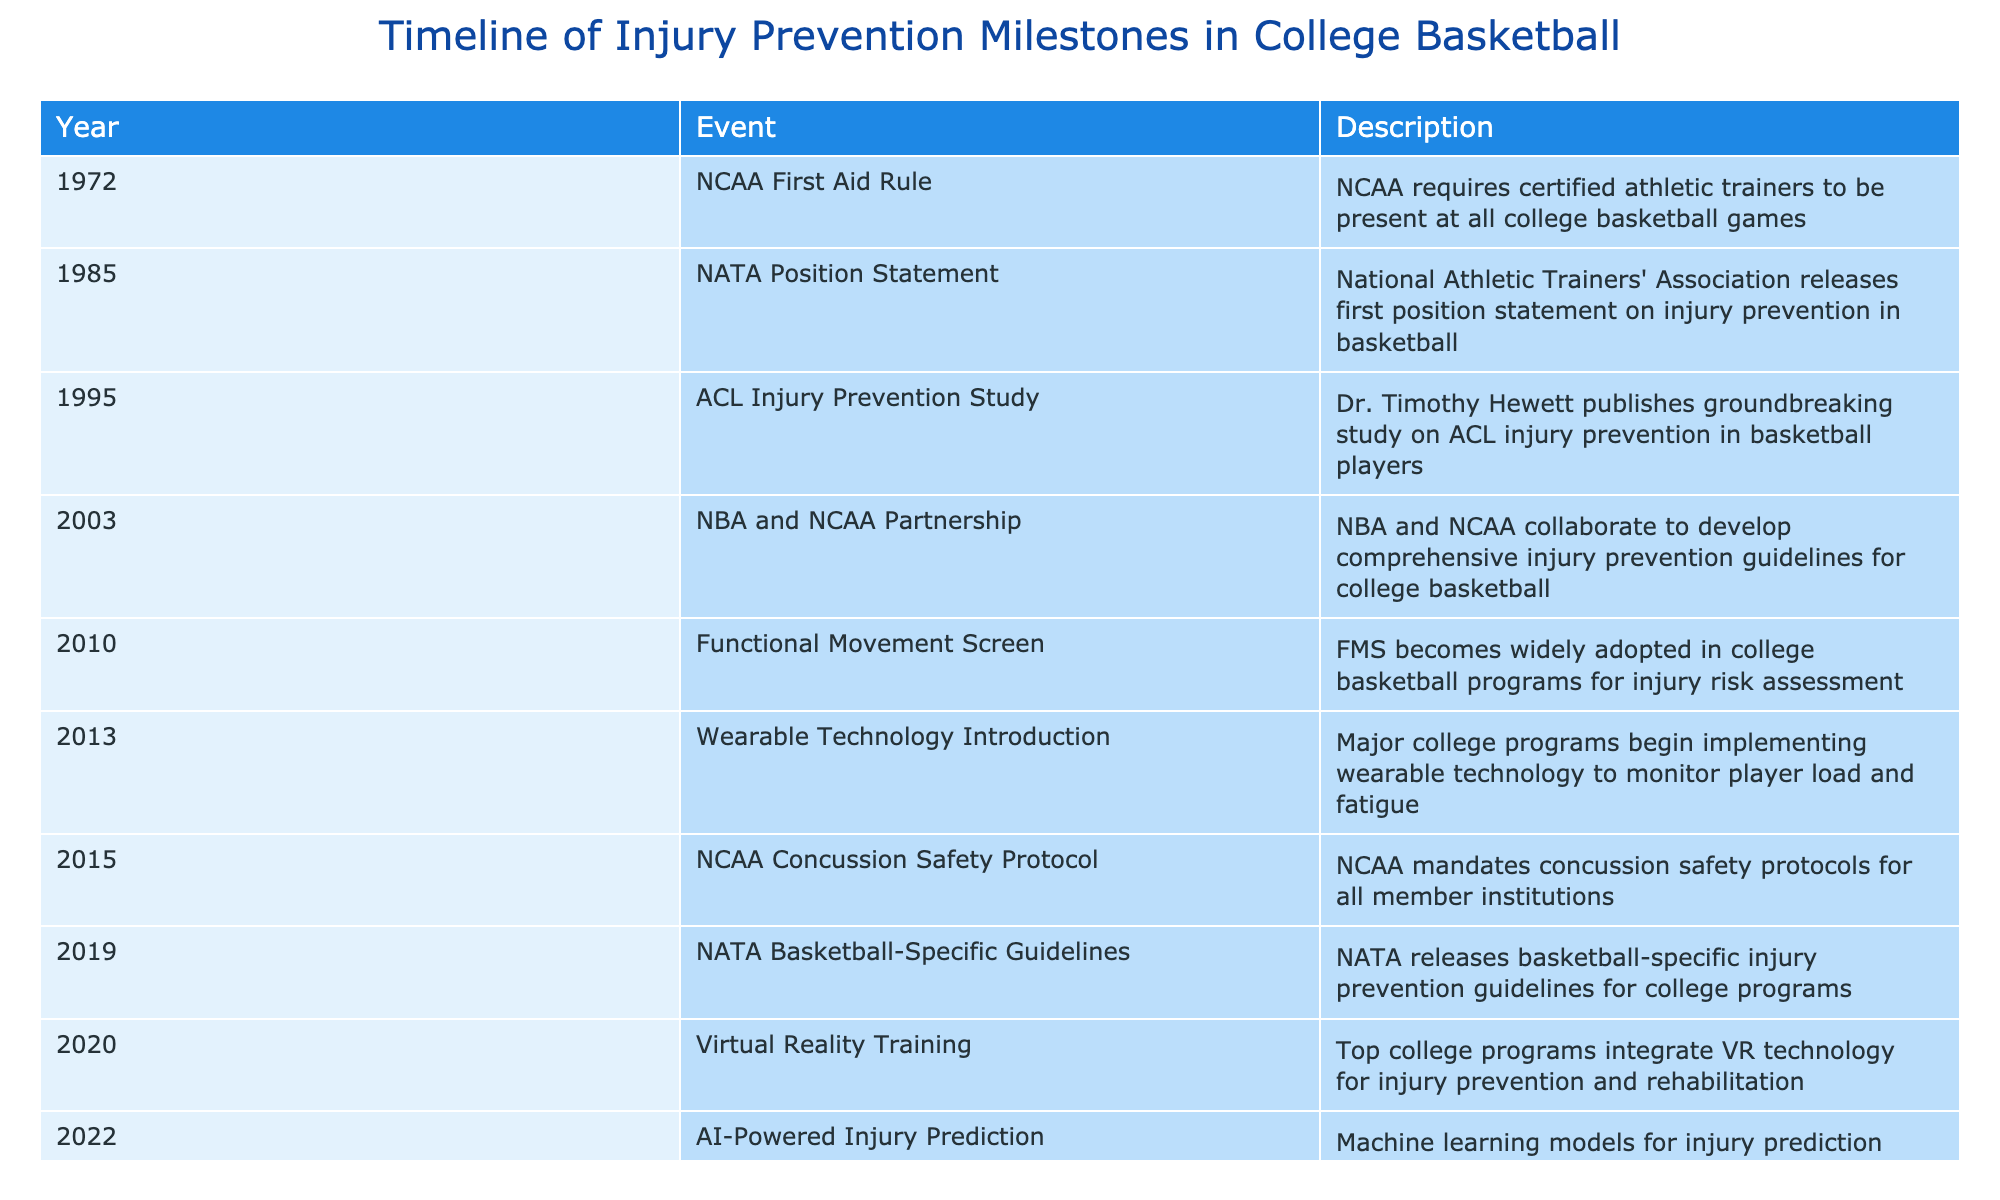What year did the NCAA first require certified athletic trainers at college basketball games? The table shows that this milestone occurred in 1972, as indicated in the 'Year' column for the 'NCAA First Aid Rule' event.
Answer: 1972 Which event in the timeline introduced wearable technology in college basketball programs? The event titled 'Wearable Technology Introduction' in 2013 indicates the beginning of this practice, as per the 'Event' and 'Year' columns.
Answer: 2013 How many significant milestones occurred in the timeline from 1985 to 2015? The milestones between these years are as follows: 1985 (NATA Position Statement), 1995 (ACL Injury Prevention Study), 2003 (NBA and NCAA Partnership), 2010 (Functional Movement Screen), and 2015 (NCAA Concussion Safety Protocol). That is a total of 5 significant milestones.
Answer: 5 Is there an event in the timeline that deals specifically with concussion safety? The 'NCAA Concussion Safety Protocol' event from 2015 addresses this, confirming that there indeed is a specific event focused on concussion safety within the given timeline.
Answer: Yes What is the difference in years between the introduction of the Functional Movement Screen and the release of the NATA Basketball-Specific Guidelines? The Functional Movement Screen was introduced in 2010 and the NATA Basketball-Specific Guidelines were released in 2019. The difference in years is calculated as 2019 - 2010 = 9 years.
Answer: 9 How many years separated the NCAA First Aid Rule from the NATA Position Statement? The NCAA First Aid Rule was implemented in 1972 and the NATA Position Statement was released in 1985. Thus, the number of years separating these events is 1985 - 1972 = 13 years.
Answer: 13 What milestone marks the introduction of AI-powered injury prediction technology? AI-powered injury prediction technology was introduced in the year 2022, as stated in the 'Year' column for that event listed in the table.
Answer: 2022 Did the introduction of Virtual Reality Training happen before or after the NATA Basketball-Specific Guidelines? The Virtual Reality Training milestone occurred in 2020, while the NATA Basketball-Specific Guidelines were released in 2019. Since 2020 is after 2019, we can determine that Virtual Reality Training was implemented after the guidelines were released.
Answer: After What are the two most recent milestones in the timeline? The last two milestones listed in the table are 'AI-Powered Injury Prediction' in 2022 and 'Virtual Reality Training' in 2020. Since we're looking for the most recent, we read the events in reverse chronological order.
Answer: AI-Powered Injury Prediction and Virtual Reality Training 